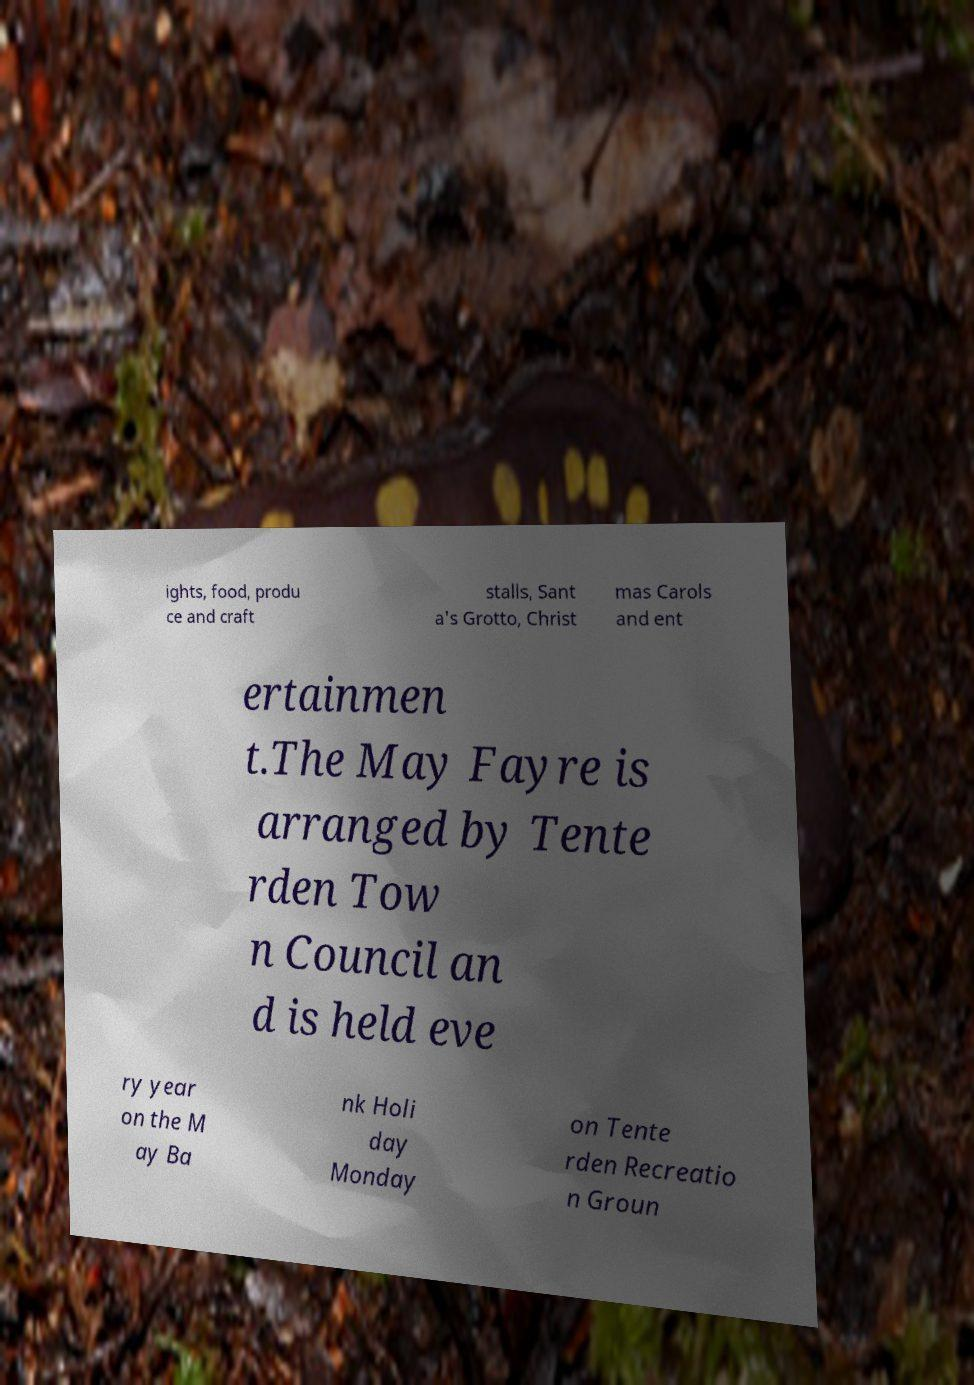Can you read and provide the text displayed in the image?This photo seems to have some interesting text. Can you extract and type it out for me? ights, food, produ ce and craft stalls, Sant a's Grotto, Christ mas Carols and ent ertainmen t.The May Fayre is arranged by Tente rden Tow n Council an d is held eve ry year on the M ay Ba nk Holi day Monday on Tente rden Recreatio n Groun 